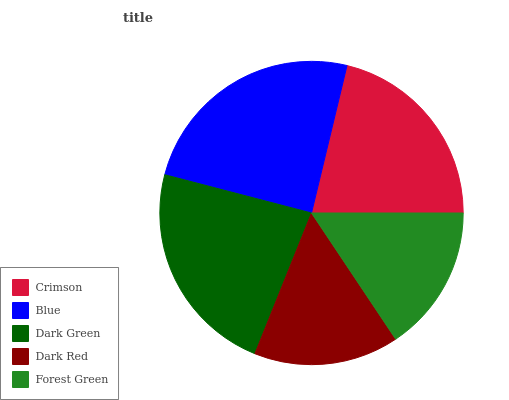Is Dark Red the minimum?
Answer yes or no. Yes. Is Blue the maximum?
Answer yes or no. Yes. Is Dark Green the minimum?
Answer yes or no. No. Is Dark Green the maximum?
Answer yes or no. No. Is Blue greater than Dark Green?
Answer yes or no. Yes. Is Dark Green less than Blue?
Answer yes or no. Yes. Is Dark Green greater than Blue?
Answer yes or no. No. Is Blue less than Dark Green?
Answer yes or no. No. Is Crimson the high median?
Answer yes or no. Yes. Is Crimson the low median?
Answer yes or no. Yes. Is Dark Green the high median?
Answer yes or no. No. Is Forest Green the low median?
Answer yes or no. No. 